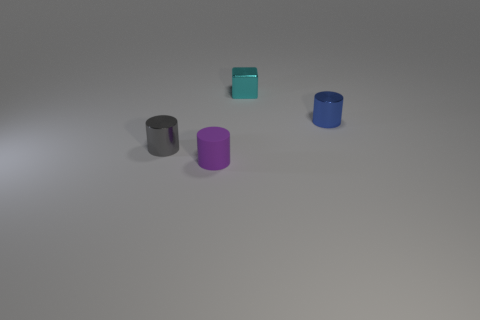Subtract all purple matte cylinders. How many cylinders are left? 2 Subtract all purple cylinders. How many cylinders are left? 2 Subtract 1 cylinders. How many cylinders are left? 2 Subtract all cylinders. How many objects are left? 1 Add 4 cyan blocks. How many objects exist? 8 Subtract all red cylinders. Subtract all blue spheres. How many cylinders are left? 3 Subtract all big cyan rubber cubes. Subtract all blue shiny cylinders. How many objects are left? 3 Add 3 tiny blue cylinders. How many tiny blue cylinders are left? 4 Add 4 tiny matte cylinders. How many tiny matte cylinders exist? 5 Subtract 0 purple balls. How many objects are left? 4 